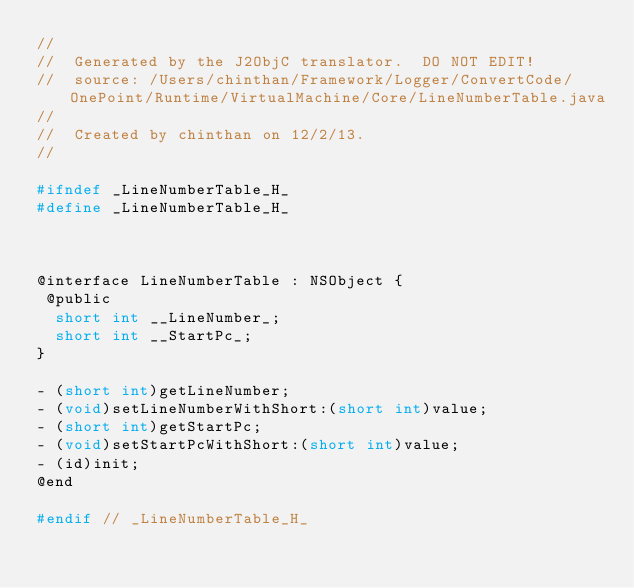Convert code to text. <code><loc_0><loc_0><loc_500><loc_500><_C_>//
//  Generated by the J2ObjC translator.  DO NOT EDIT!
//  source: /Users/chinthan/Framework/Logger/ConvertCode/OnePoint/Runtime/VirtualMachine/Core/LineNumberTable.java
//
//  Created by chinthan on 12/2/13.
//

#ifndef _LineNumberTable_H_
#define _LineNumberTable_H_



@interface LineNumberTable : NSObject {
 @public
  short int __LineNumber_;
  short int __StartPc_;
}

- (short int)getLineNumber;
- (void)setLineNumberWithShort:(short int)value;
- (short int)getStartPc;
- (void)setStartPcWithShort:(short int)value;
- (id)init;
@end

#endif // _LineNumberTable_H_
</code> 